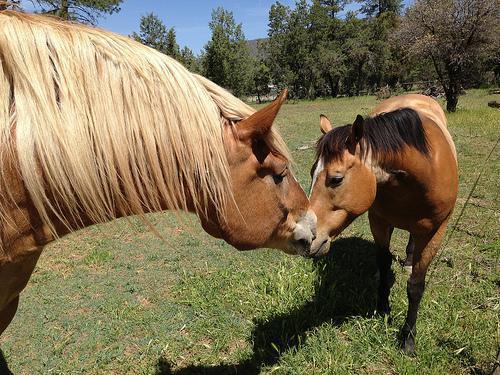How many horses on the field?
Give a very brief answer. 2. 